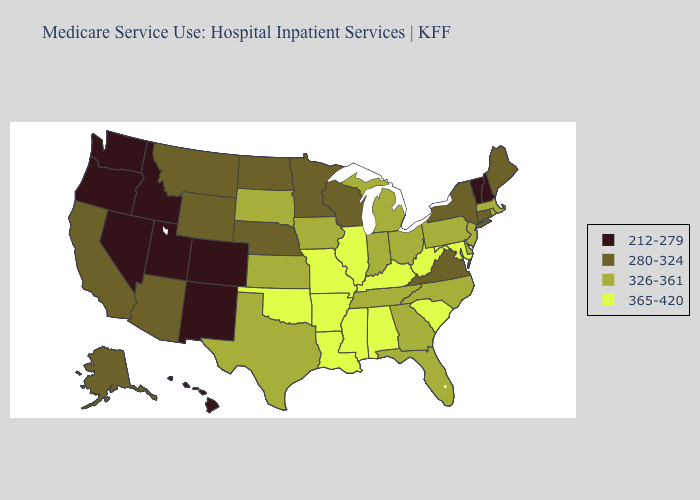What is the value of Kansas?
Be succinct. 326-361. What is the value of West Virginia?
Concise answer only. 365-420. What is the highest value in the Northeast ?
Keep it brief. 326-361. Does Oklahoma have the highest value in the South?
Quick response, please. Yes. Name the states that have a value in the range 326-361?
Write a very short answer. Delaware, Florida, Georgia, Indiana, Iowa, Kansas, Massachusetts, Michigan, New Jersey, North Carolina, Ohio, Pennsylvania, Rhode Island, South Dakota, Tennessee, Texas. Among the states that border Ohio , which have the lowest value?
Keep it brief. Indiana, Michigan, Pennsylvania. Does New Mexico have a lower value than Nebraska?
Quick response, please. Yes. Does South Dakota have the lowest value in the MidWest?
Give a very brief answer. No. Name the states that have a value in the range 280-324?
Be succinct. Alaska, Arizona, California, Connecticut, Maine, Minnesota, Montana, Nebraska, New York, North Dakota, Virginia, Wisconsin, Wyoming. Does the map have missing data?
Be succinct. No. What is the highest value in states that border Ohio?
Quick response, please. 365-420. What is the value of Tennessee?
Short answer required. 326-361. What is the value of South Dakota?
Be succinct. 326-361. What is the value of South Dakota?
Short answer required. 326-361. 